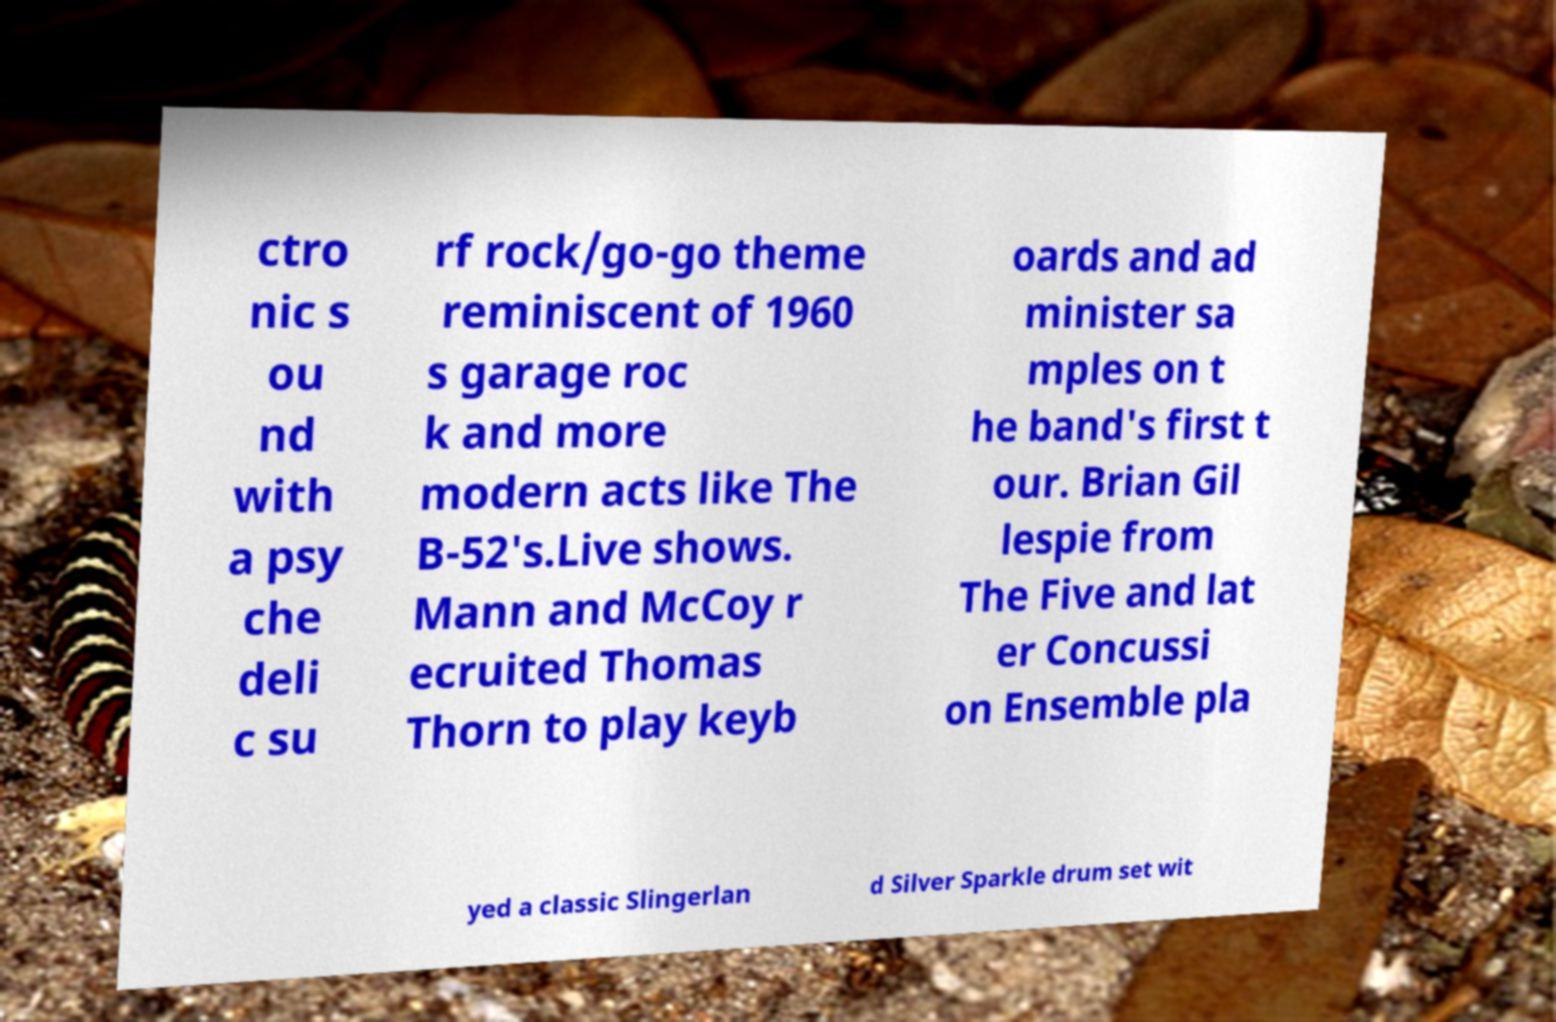For documentation purposes, I need the text within this image transcribed. Could you provide that? ctro nic s ou nd with a psy che deli c su rf rock/go-go theme reminiscent of 1960 s garage roc k and more modern acts like The B-52's.Live shows. Mann and McCoy r ecruited Thomas Thorn to play keyb oards and ad minister sa mples on t he band's first t our. Brian Gil lespie from The Five and lat er Concussi on Ensemble pla yed a classic Slingerlan d Silver Sparkle drum set wit 